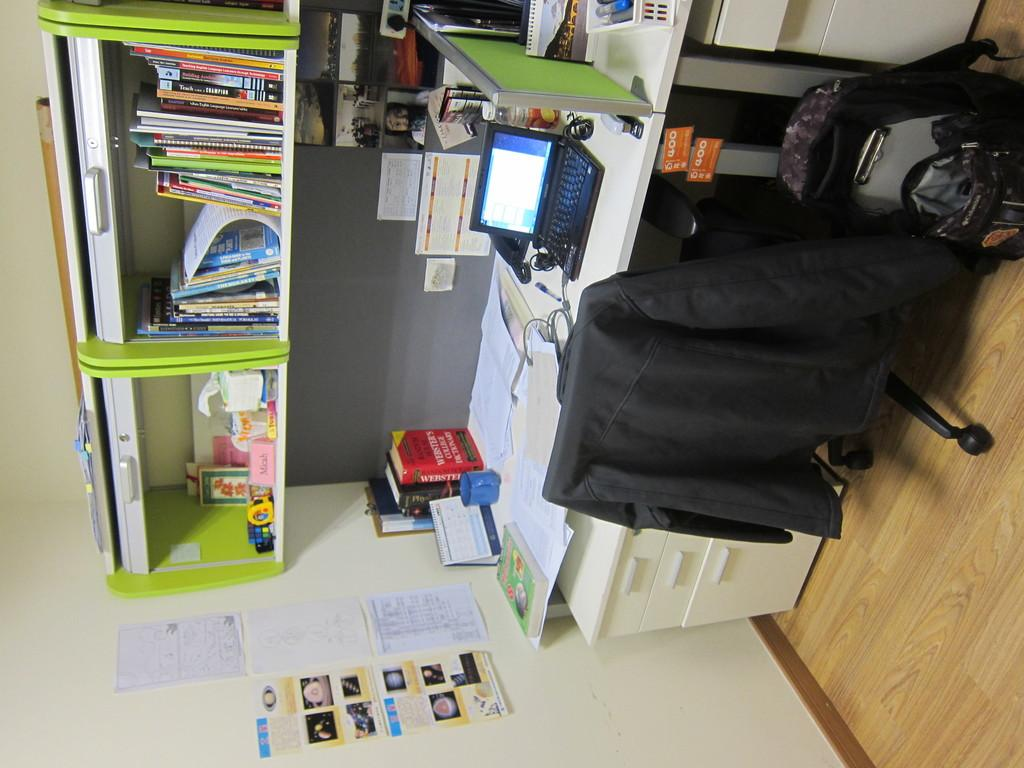<image>
Present a compact description of the photo's key features. A black book whose title starts with T is on a shelf over someone's desk. 